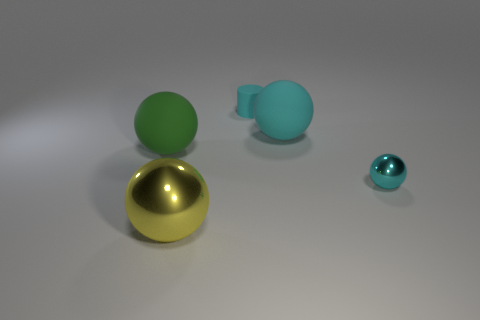Add 4 small yellow rubber blocks. How many objects exist? 9 Subtract all large cyan balls. How many balls are left? 3 Subtract all green spheres. How many spheres are left? 3 Subtract all cylinders. How many objects are left? 4 Subtract all brown blocks. How many yellow spheres are left? 1 Subtract all small cylinders. Subtract all matte cylinders. How many objects are left? 3 Add 4 small spheres. How many small spheres are left? 5 Add 1 brown metallic blocks. How many brown metallic blocks exist? 1 Subtract 0 purple cylinders. How many objects are left? 5 Subtract 2 balls. How many balls are left? 2 